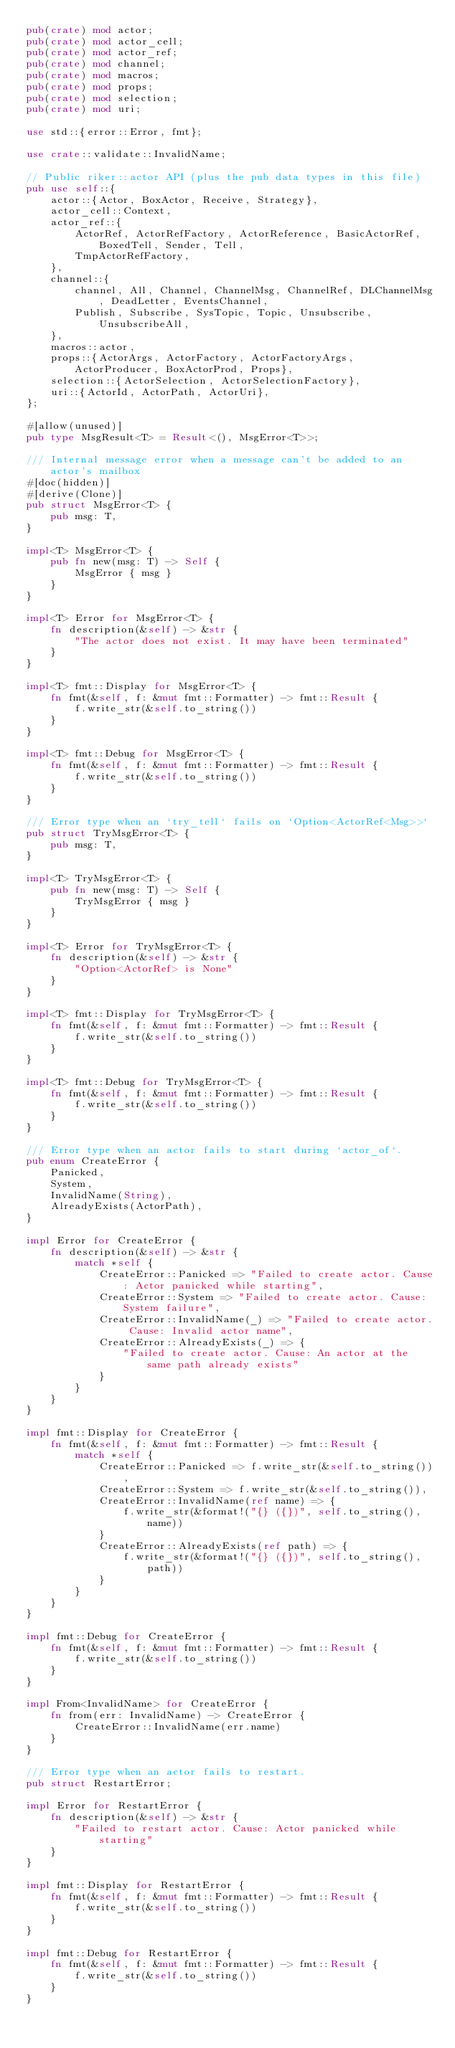<code> <loc_0><loc_0><loc_500><loc_500><_Rust_>pub(crate) mod actor;
pub(crate) mod actor_cell;
pub(crate) mod actor_ref;
pub(crate) mod channel;
pub(crate) mod macros;
pub(crate) mod props;
pub(crate) mod selection;
pub(crate) mod uri;

use std::{error::Error, fmt};

use crate::validate::InvalidName;

// Public riker::actor API (plus the pub data types in this file)
pub use self::{
    actor::{Actor, BoxActor, Receive, Strategy},
    actor_cell::Context,
    actor_ref::{
        ActorRef, ActorRefFactory, ActorReference, BasicActorRef, BoxedTell, Sender, Tell,
        TmpActorRefFactory,
    },
    channel::{
        channel, All, Channel, ChannelMsg, ChannelRef, DLChannelMsg, DeadLetter, EventsChannel,
        Publish, Subscribe, SysTopic, Topic, Unsubscribe, UnsubscribeAll,
    },
    macros::actor,
    props::{ActorArgs, ActorFactory, ActorFactoryArgs, ActorProducer, BoxActorProd, Props},
    selection::{ActorSelection, ActorSelectionFactory},
    uri::{ActorId, ActorPath, ActorUri},
};

#[allow(unused)]
pub type MsgResult<T> = Result<(), MsgError<T>>;

/// Internal message error when a message can't be added to an actor's mailbox
#[doc(hidden)]
#[derive(Clone)]
pub struct MsgError<T> {
    pub msg: T,
}

impl<T> MsgError<T> {
    pub fn new(msg: T) -> Self {
        MsgError { msg }
    }
}

impl<T> Error for MsgError<T> {
    fn description(&self) -> &str {
        "The actor does not exist. It may have been terminated"
    }
}

impl<T> fmt::Display for MsgError<T> {
    fn fmt(&self, f: &mut fmt::Formatter) -> fmt::Result {
        f.write_str(&self.to_string())
    }
}

impl<T> fmt::Debug for MsgError<T> {
    fn fmt(&self, f: &mut fmt::Formatter) -> fmt::Result {
        f.write_str(&self.to_string())
    }
}

/// Error type when an `try_tell` fails on `Option<ActorRef<Msg>>`
pub struct TryMsgError<T> {
    pub msg: T,
}

impl<T> TryMsgError<T> {
    pub fn new(msg: T) -> Self {
        TryMsgError { msg }
    }
}

impl<T> Error for TryMsgError<T> {
    fn description(&self) -> &str {
        "Option<ActorRef> is None"
    }
}

impl<T> fmt::Display for TryMsgError<T> {
    fn fmt(&self, f: &mut fmt::Formatter) -> fmt::Result {
        f.write_str(&self.to_string())
    }
}

impl<T> fmt::Debug for TryMsgError<T> {
    fn fmt(&self, f: &mut fmt::Formatter) -> fmt::Result {
        f.write_str(&self.to_string())
    }
}

/// Error type when an actor fails to start during `actor_of`.
pub enum CreateError {
    Panicked,
    System,
    InvalidName(String),
    AlreadyExists(ActorPath),
}

impl Error for CreateError {
    fn description(&self) -> &str {
        match *self {
            CreateError::Panicked => "Failed to create actor. Cause: Actor panicked while starting",
            CreateError::System => "Failed to create actor. Cause: System failure",
            CreateError::InvalidName(_) => "Failed to create actor. Cause: Invalid actor name",
            CreateError::AlreadyExists(_) => {
                "Failed to create actor. Cause: An actor at the same path already exists"
            }
        }
    }
}

impl fmt::Display for CreateError {
    fn fmt(&self, f: &mut fmt::Formatter) -> fmt::Result {
        match *self {
            CreateError::Panicked => f.write_str(&self.to_string()),
            CreateError::System => f.write_str(&self.to_string()),
            CreateError::InvalidName(ref name) => {
                f.write_str(&format!("{} ({})", self.to_string(), name))
            }
            CreateError::AlreadyExists(ref path) => {
                f.write_str(&format!("{} ({})", self.to_string(), path))
            }
        }
    }
}

impl fmt::Debug for CreateError {
    fn fmt(&self, f: &mut fmt::Formatter) -> fmt::Result {
        f.write_str(&self.to_string())
    }
}

impl From<InvalidName> for CreateError {
    fn from(err: InvalidName) -> CreateError {
        CreateError::InvalidName(err.name)
    }
}

/// Error type when an actor fails to restart.
pub struct RestartError;

impl Error for RestartError {
    fn description(&self) -> &str {
        "Failed to restart actor. Cause: Actor panicked while starting"
    }
}

impl fmt::Display for RestartError {
    fn fmt(&self, f: &mut fmt::Formatter) -> fmt::Result {
        f.write_str(&self.to_string())
    }
}

impl fmt::Debug for RestartError {
    fn fmt(&self, f: &mut fmt::Formatter) -> fmt::Result {
        f.write_str(&self.to_string())
    }
}
</code> 